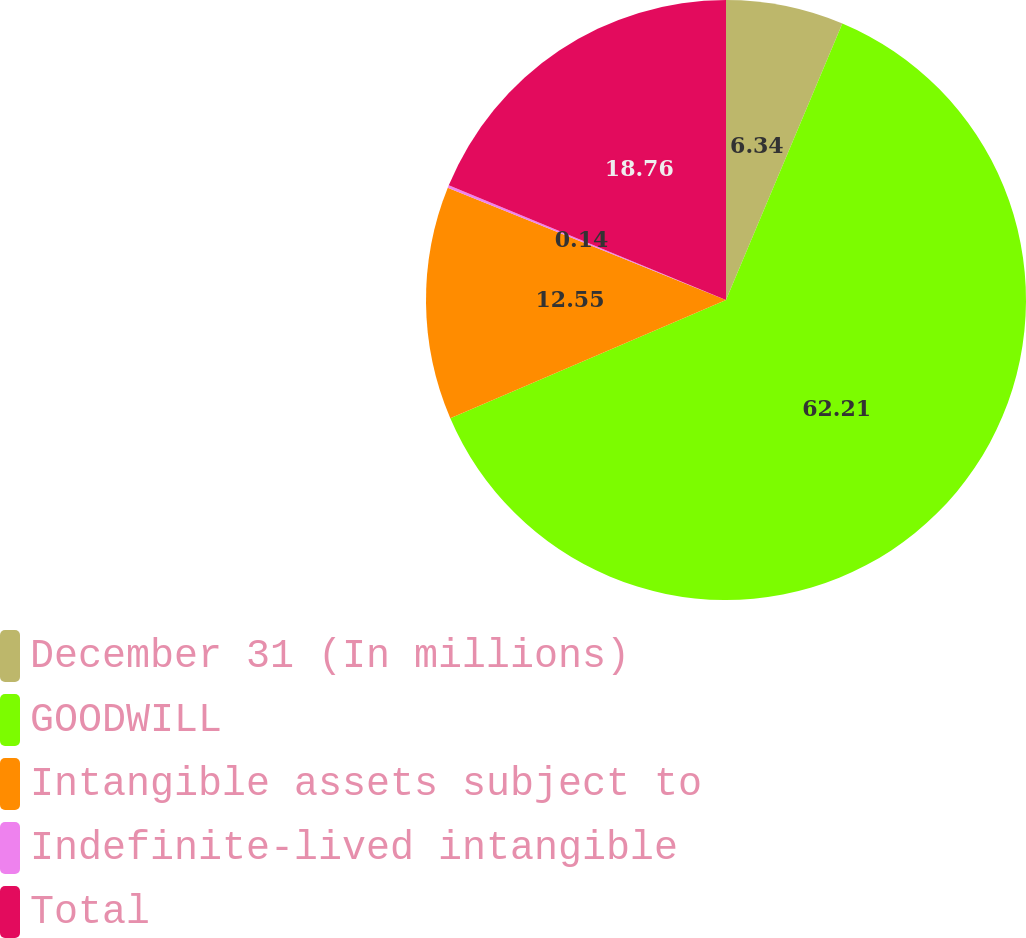Convert chart to OTSL. <chart><loc_0><loc_0><loc_500><loc_500><pie_chart><fcel>December 31 (In millions)<fcel>GOODWILL<fcel>Intangible assets subject to<fcel>Indefinite-lived intangible<fcel>Total<nl><fcel>6.34%<fcel>62.21%<fcel>12.55%<fcel>0.14%<fcel>18.76%<nl></chart> 